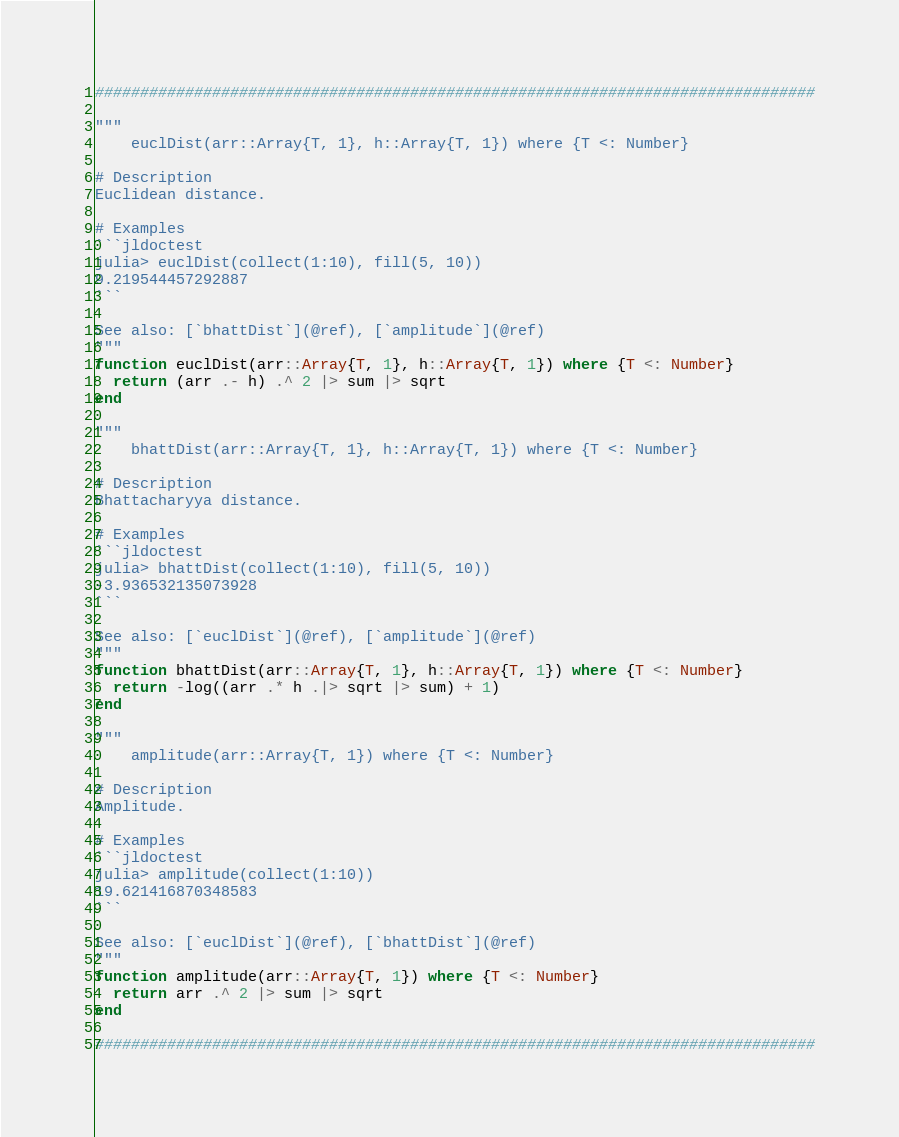Convert code to text. <code><loc_0><loc_0><loc_500><loc_500><_Julia_>################################################################################

"""
    euclDist(arr::Array{T, 1}, h::Array{T, 1}) where {T <: Number}

# Description
Euclidean distance.

# Examples
```jldoctest
julia> euclDist(collect(1:10), fill(5, 10))
9.219544457292887
```

See also: [`bhattDist`](@ref), [`amplitude`](@ref)
"""
function euclDist(arr::Array{T, 1}, h::Array{T, 1}) where {T <: Number}
  return (arr .- h) .^ 2 |> sum |> sqrt
end

"""
    bhattDist(arr::Array{T, 1}, h::Array{T, 1}) where {T <: Number}

# Description
Bhattacharyya distance.

# Examples
```jldoctest
julia> bhattDist(collect(1:10), fill(5, 10))
-3.936532135073928
```

See also: [`euclDist`](@ref), [`amplitude`](@ref)
"""
function bhattDist(arr::Array{T, 1}, h::Array{T, 1}) where {T <: Number}
  return -log((arr .* h .|> sqrt |> sum) + 1)
end

"""
    amplitude(arr::Array{T, 1}) where {T <: Number}

# Description
Amplitude.

# Examples
```jldoctest
julia> amplitude(collect(1:10))
19.621416870348583
```

See also: [`euclDist`](@ref), [`bhattDist`](@ref)
"""
function amplitude(arr::Array{T, 1}) where {T <: Number}
  return arr .^ 2 |> sum |> sqrt
end

################################################################################
</code> 